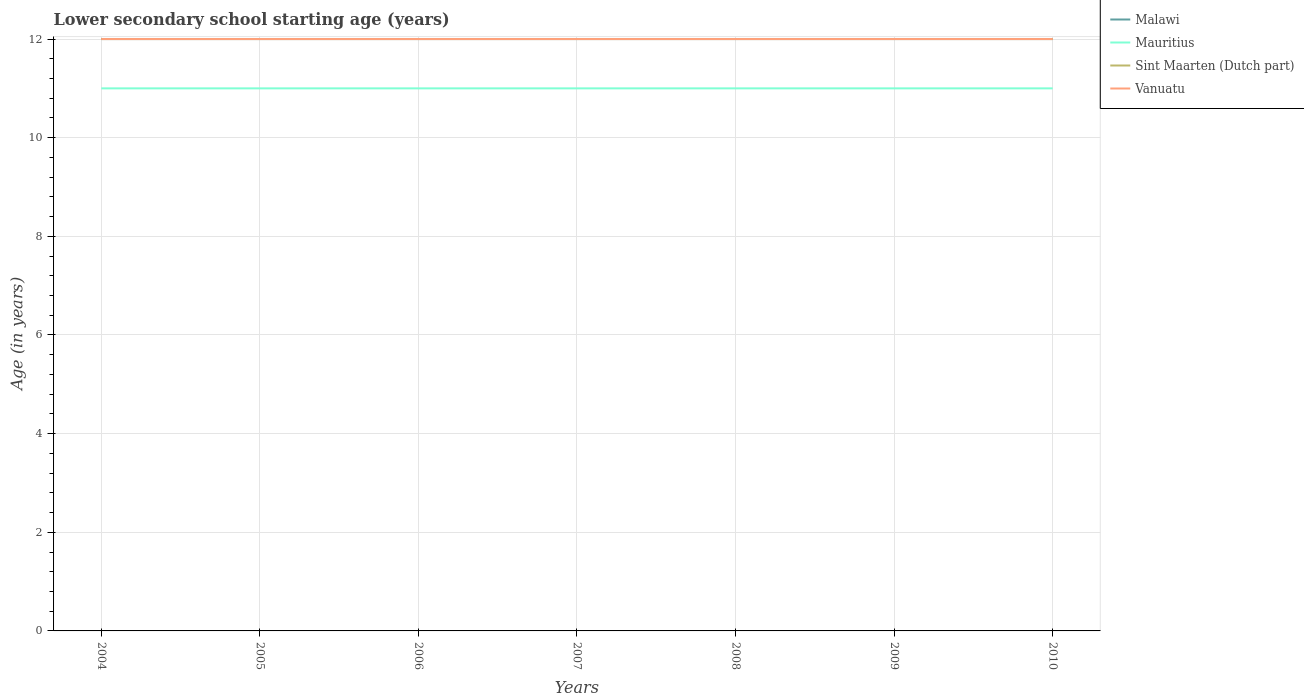Does the line corresponding to Vanuatu intersect with the line corresponding to Malawi?
Your response must be concise. Yes. Across all years, what is the maximum lower secondary school starting age of children in Sint Maarten (Dutch part)?
Your response must be concise. 12. In which year was the lower secondary school starting age of children in Malawi maximum?
Ensure brevity in your answer.  2004. What is the difference between the highest and the second highest lower secondary school starting age of children in Malawi?
Provide a short and direct response. 0. What is the difference between the highest and the lowest lower secondary school starting age of children in Mauritius?
Give a very brief answer. 0. How many lines are there?
Your answer should be very brief. 4. What is the difference between two consecutive major ticks on the Y-axis?
Your answer should be compact. 2. Are the values on the major ticks of Y-axis written in scientific E-notation?
Provide a succinct answer. No. Does the graph contain any zero values?
Provide a short and direct response. No. Does the graph contain grids?
Your response must be concise. Yes. Where does the legend appear in the graph?
Make the answer very short. Top right. How many legend labels are there?
Make the answer very short. 4. How are the legend labels stacked?
Give a very brief answer. Vertical. What is the title of the graph?
Give a very brief answer. Lower secondary school starting age (years). Does "Estonia" appear as one of the legend labels in the graph?
Make the answer very short. No. What is the label or title of the Y-axis?
Give a very brief answer. Age (in years). What is the Age (in years) of Malawi in 2004?
Offer a very short reply. 12. What is the Age (in years) in Mauritius in 2004?
Provide a short and direct response. 11. What is the Age (in years) in Sint Maarten (Dutch part) in 2004?
Your answer should be compact. 12. What is the Age (in years) of Mauritius in 2005?
Your answer should be very brief. 11. What is the Age (in years) in Sint Maarten (Dutch part) in 2005?
Keep it short and to the point. 12. What is the Age (in years) in Vanuatu in 2005?
Your answer should be very brief. 12. What is the Age (in years) in Malawi in 2007?
Provide a succinct answer. 12. What is the Age (in years) of Mauritius in 2007?
Ensure brevity in your answer.  11. What is the Age (in years) in Vanuatu in 2007?
Your response must be concise. 12. What is the Age (in years) in Mauritius in 2008?
Provide a short and direct response. 11. What is the Age (in years) of Sint Maarten (Dutch part) in 2008?
Your answer should be compact. 12. What is the Age (in years) in Malawi in 2009?
Offer a terse response. 12. What is the Age (in years) in Mauritius in 2009?
Provide a short and direct response. 11. What is the Age (in years) in Sint Maarten (Dutch part) in 2009?
Give a very brief answer. 12. What is the Age (in years) of Vanuatu in 2009?
Keep it short and to the point. 12. What is the Age (in years) in Mauritius in 2010?
Your answer should be very brief. 11. What is the Age (in years) of Sint Maarten (Dutch part) in 2010?
Ensure brevity in your answer.  12. What is the Age (in years) in Vanuatu in 2010?
Keep it short and to the point. 12. Across all years, what is the maximum Age (in years) of Malawi?
Your answer should be very brief. 12. Across all years, what is the maximum Age (in years) of Mauritius?
Provide a short and direct response. 11. Across all years, what is the maximum Age (in years) in Vanuatu?
Give a very brief answer. 12. Across all years, what is the minimum Age (in years) in Sint Maarten (Dutch part)?
Give a very brief answer. 12. What is the total Age (in years) of Mauritius in the graph?
Keep it short and to the point. 77. What is the difference between the Age (in years) of Mauritius in 2004 and that in 2005?
Make the answer very short. 0. What is the difference between the Age (in years) of Vanuatu in 2004 and that in 2005?
Provide a succinct answer. 0. What is the difference between the Age (in years) in Mauritius in 2004 and that in 2006?
Keep it short and to the point. 0. What is the difference between the Age (in years) of Sint Maarten (Dutch part) in 2004 and that in 2006?
Your answer should be very brief. 0. What is the difference between the Age (in years) in Vanuatu in 2004 and that in 2006?
Your answer should be compact. 0. What is the difference between the Age (in years) of Malawi in 2004 and that in 2007?
Give a very brief answer. 0. What is the difference between the Age (in years) in Mauritius in 2004 and that in 2007?
Your answer should be compact. 0. What is the difference between the Age (in years) in Sint Maarten (Dutch part) in 2004 and that in 2007?
Provide a succinct answer. 0. What is the difference between the Age (in years) of Vanuatu in 2004 and that in 2007?
Give a very brief answer. 0. What is the difference between the Age (in years) in Mauritius in 2004 and that in 2008?
Offer a very short reply. 0. What is the difference between the Age (in years) of Sint Maarten (Dutch part) in 2004 and that in 2008?
Offer a very short reply. 0. What is the difference between the Age (in years) in Vanuatu in 2004 and that in 2008?
Provide a succinct answer. 0. What is the difference between the Age (in years) in Sint Maarten (Dutch part) in 2004 and that in 2009?
Give a very brief answer. 0. What is the difference between the Age (in years) of Vanuatu in 2004 and that in 2009?
Make the answer very short. 0. What is the difference between the Age (in years) in Malawi in 2004 and that in 2010?
Your answer should be very brief. 0. What is the difference between the Age (in years) in Malawi in 2005 and that in 2006?
Your response must be concise. 0. What is the difference between the Age (in years) in Mauritius in 2005 and that in 2006?
Offer a very short reply. 0. What is the difference between the Age (in years) of Sint Maarten (Dutch part) in 2005 and that in 2007?
Make the answer very short. 0. What is the difference between the Age (in years) of Vanuatu in 2005 and that in 2007?
Keep it short and to the point. 0. What is the difference between the Age (in years) of Vanuatu in 2005 and that in 2008?
Offer a terse response. 0. What is the difference between the Age (in years) of Malawi in 2005 and that in 2009?
Make the answer very short. 0. What is the difference between the Age (in years) of Sint Maarten (Dutch part) in 2005 and that in 2009?
Provide a short and direct response. 0. What is the difference between the Age (in years) of Vanuatu in 2005 and that in 2009?
Offer a terse response. 0. What is the difference between the Age (in years) of Vanuatu in 2005 and that in 2010?
Give a very brief answer. 0. What is the difference between the Age (in years) of Sint Maarten (Dutch part) in 2006 and that in 2007?
Keep it short and to the point. 0. What is the difference between the Age (in years) of Malawi in 2006 and that in 2008?
Your answer should be compact. 0. What is the difference between the Age (in years) of Vanuatu in 2006 and that in 2008?
Make the answer very short. 0. What is the difference between the Age (in years) of Sint Maarten (Dutch part) in 2006 and that in 2009?
Offer a very short reply. 0. What is the difference between the Age (in years) of Sint Maarten (Dutch part) in 2006 and that in 2010?
Make the answer very short. 0. What is the difference between the Age (in years) in Malawi in 2007 and that in 2008?
Your response must be concise. 0. What is the difference between the Age (in years) in Mauritius in 2007 and that in 2008?
Ensure brevity in your answer.  0. What is the difference between the Age (in years) in Sint Maarten (Dutch part) in 2007 and that in 2008?
Your response must be concise. 0. What is the difference between the Age (in years) of Malawi in 2007 and that in 2009?
Keep it short and to the point. 0. What is the difference between the Age (in years) of Mauritius in 2007 and that in 2009?
Provide a short and direct response. 0. What is the difference between the Age (in years) in Vanuatu in 2007 and that in 2009?
Provide a short and direct response. 0. What is the difference between the Age (in years) in Malawi in 2007 and that in 2010?
Your answer should be very brief. 0. What is the difference between the Age (in years) in Malawi in 2008 and that in 2009?
Ensure brevity in your answer.  0. What is the difference between the Age (in years) of Sint Maarten (Dutch part) in 2008 and that in 2009?
Your answer should be compact. 0. What is the difference between the Age (in years) in Vanuatu in 2008 and that in 2009?
Your response must be concise. 0. What is the difference between the Age (in years) in Mauritius in 2008 and that in 2010?
Keep it short and to the point. 0. What is the difference between the Age (in years) in Sint Maarten (Dutch part) in 2008 and that in 2010?
Your answer should be compact. 0. What is the difference between the Age (in years) in Vanuatu in 2008 and that in 2010?
Your answer should be very brief. 0. What is the difference between the Age (in years) in Malawi in 2009 and that in 2010?
Give a very brief answer. 0. What is the difference between the Age (in years) of Mauritius in 2009 and that in 2010?
Your response must be concise. 0. What is the difference between the Age (in years) in Malawi in 2004 and the Age (in years) in Mauritius in 2005?
Your answer should be very brief. 1. What is the difference between the Age (in years) of Malawi in 2004 and the Age (in years) of Sint Maarten (Dutch part) in 2005?
Ensure brevity in your answer.  0. What is the difference between the Age (in years) in Malawi in 2004 and the Age (in years) in Vanuatu in 2005?
Your answer should be very brief. 0. What is the difference between the Age (in years) of Sint Maarten (Dutch part) in 2004 and the Age (in years) of Vanuatu in 2005?
Ensure brevity in your answer.  0. What is the difference between the Age (in years) in Malawi in 2004 and the Age (in years) in Mauritius in 2006?
Give a very brief answer. 1. What is the difference between the Age (in years) in Malawi in 2004 and the Age (in years) in Vanuatu in 2006?
Your answer should be compact. 0. What is the difference between the Age (in years) of Mauritius in 2004 and the Age (in years) of Sint Maarten (Dutch part) in 2006?
Ensure brevity in your answer.  -1. What is the difference between the Age (in years) in Sint Maarten (Dutch part) in 2004 and the Age (in years) in Vanuatu in 2006?
Keep it short and to the point. 0. What is the difference between the Age (in years) of Malawi in 2004 and the Age (in years) of Mauritius in 2007?
Offer a terse response. 1. What is the difference between the Age (in years) of Malawi in 2004 and the Age (in years) of Sint Maarten (Dutch part) in 2007?
Provide a short and direct response. 0. What is the difference between the Age (in years) of Mauritius in 2004 and the Age (in years) of Sint Maarten (Dutch part) in 2007?
Provide a succinct answer. -1. What is the difference between the Age (in years) of Mauritius in 2004 and the Age (in years) of Vanuatu in 2007?
Provide a short and direct response. -1. What is the difference between the Age (in years) in Malawi in 2004 and the Age (in years) in Sint Maarten (Dutch part) in 2008?
Your answer should be compact. 0. What is the difference between the Age (in years) of Malawi in 2004 and the Age (in years) of Vanuatu in 2008?
Give a very brief answer. 0. What is the difference between the Age (in years) of Mauritius in 2004 and the Age (in years) of Vanuatu in 2008?
Ensure brevity in your answer.  -1. What is the difference between the Age (in years) in Sint Maarten (Dutch part) in 2004 and the Age (in years) in Vanuatu in 2008?
Make the answer very short. 0. What is the difference between the Age (in years) in Mauritius in 2004 and the Age (in years) in Vanuatu in 2009?
Keep it short and to the point. -1. What is the difference between the Age (in years) of Malawi in 2004 and the Age (in years) of Sint Maarten (Dutch part) in 2010?
Ensure brevity in your answer.  0. What is the difference between the Age (in years) of Sint Maarten (Dutch part) in 2004 and the Age (in years) of Vanuatu in 2010?
Make the answer very short. 0. What is the difference between the Age (in years) of Malawi in 2005 and the Age (in years) of Mauritius in 2006?
Keep it short and to the point. 1. What is the difference between the Age (in years) of Malawi in 2005 and the Age (in years) of Sint Maarten (Dutch part) in 2006?
Offer a very short reply. 0. What is the difference between the Age (in years) in Malawi in 2005 and the Age (in years) in Vanuatu in 2006?
Keep it short and to the point. 0. What is the difference between the Age (in years) in Mauritius in 2005 and the Age (in years) in Sint Maarten (Dutch part) in 2006?
Provide a short and direct response. -1. What is the difference between the Age (in years) in Malawi in 2005 and the Age (in years) in Mauritius in 2007?
Ensure brevity in your answer.  1. What is the difference between the Age (in years) of Mauritius in 2005 and the Age (in years) of Sint Maarten (Dutch part) in 2007?
Your answer should be compact. -1. What is the difference between the Age (in years) of Mauritius in 2005 and the Age (in years) of Vanuatu in 2007?
Ensure brevity in your answer.  -1. What is the difference between the Age (in years) in Sint Maarten (Dutch part) in 2005 and the Age (in years) in Vanuatu in 2007?
Provide a succinct answer. 0. What is the difference between the Age (in years) in Malawi in 2005 and the Age (in years) in Sint Maarten (Dutch part) in 2008?
Your answer should be compact. 0. What is the difference between the Age (in years) of Malawi in 2005 and the Age (in years) of Vanuatu in 2008?
Your response must be concise. 0. What is the difference between the Age (in years) in Malawi in 2005 and the Age (in years) in Sint Maarten (Dutch part) in 2009?
Provide a succinct answer. 0. What is the difference between the Age (in years) in Malawi in 2005 and the Age (in years) in Vanuatu in 2009?
Ensure brevity in your answer.  0. What is the difference between the Age (in years) in Mauritius in 2005 and the Age (in years) in Sint Maarten (Dutch part) in 2009?
Provide a short and direct response. -1. What is the difference between the Age (in years) in Malawi in 2005 and the Age (in years) in Mauritius in 2010?
Offer a very short reply. 1. What is the difference between the Age (in years) of Malawi in 2005 and the Age (in years) of Sint Maarten (Dutch part) in 2010?
Give a very brief answer. 0. What is the difference between the Age (in years) of Malawi in 2005 and the Age (in years) of Vanuatu in 2010?
Provide a short and direct response. 0. What is the difference between the Age (in years) in Mauritius in 2005 and the Age (in years) in Vanuatu in 2010?
Your response must be concise. -1. What is the difference between the Age (in years) in Sint Maarten (Dutch part) in 2005 and the Age (in years) in Vanuatu in 2010?
Keep it short and to the point. 0. What is the difference between the Age (in years) of Malawi in 2006 and the Age (in years) of Mauritius in 2007?
Your answer should be very brief. 1. What is the difference between the Age (in years) of Mauritius in 2006 and the Age (in years) of Vanuatu in 2007?
Provide a short and direct response. -1. What is the difference between the Age (in years) in Malawi in 2006 and the Age (in years) in Mauritius in 2008?
Provide a short and direct response. 1. What is the difference between the Age (in years) of Malawi in 2006 and the Age (in years) of Vanuatu in 2008?
Your answer should be compact. 0. What is the difference between the Age (in years) in Mauritius in 2006 and the Age (in years) in Sint Maarten (Dutch part) in 2008?
Provide a succinct answer. -1. What is the difference between the Age (in years) in Sint Maarten (Dutch part) in 2006 and the Age (in years) in Vanuatu in 2008?
Keep it short and to the point. 0. What is the difference between the Age (in years) of Malawi in 2006 and the Age (in years) of Mauritius in 2009?
Make the answer very short. 1. What is the difference between the Age (in years) in Malawi in 2006 and the Age (in years) in Sint Maarten (Dutch part) in 2009?
Your answer should be very brief. 0. What is the difference between the Age (in years) in Malawi in 2006 and the Age (in years) in Vanuatu in 2009?
Keep it short and to the point. 0. What is the difference between the Age (in years) in Mauritius in 2006 and the Age (in years) in Sint Maarten (Dutch part) in 2009?
Keep it short and to the point. -1. What is the difference between the Age (in years) of Mauritius in 2006 and the Age (in years) of Vanuatu in 2009?
Provide a succinct answer. -1. What is the difference between the Age (in years) of Malawi in 2006 and the Age (in years) of Mauritius in 2010?
Offer a very short reply. 1. What is the difference between the Age (in years) in Malawi in 2006 and the Age (in years) in Vanuatu in 2010?
Your answer should be very brief. 0. What is the difference between the Age (in years) of Mauritius in 2006 and the Age (in years) of Vanuatu in 2010?
Make the answer very short. -1. What is the difference between the Age (in years) in Malawi in 2007 and the Age (in years) in Mauritius in 2008?
Your answer should be very brief. 1. What is the difference between the Age (in years) in Malawi in 2007 and the Age (in years) in Sint Maarten (Dutch part) in 2008?
Your answer should be compact. 0. What is the difference between the Age (in years) of Mauritius in 2007 and the Age (in years) of Sint Maarten (Dutch part) in 2008?
Your response must be concise. -1. What is the difference between the Age (in years) in Mauritius in 2007 and the Age (in years) in Vanuatu in 2008?
Ensure brevity in your answer.  -1. What is the difference between the Age (in years) of Sint Maarten (Dutch part) in 2007 and the Age (in years) of Vanuatu in 2008?
Keep it short and to the point. 0. What is the difference between the Age (in years) of Mauritius in 2007 and the Age (in years) of Sint Maarten (Dutch part) in 2009?
Provide a succinct answer. -1. What is the difference between the Age (in years) of Mauritius in 2007 and the Age (in years) of Vanuatu in 2009?
Offer a very short reply. -1. What is the difference between the Age (in years) in Malawi in 2007 and the Age (in years) in Mauritius in 2010?
Your response must be concise. 1. What is the difference between the Age (in years) in Malawi in 2007 and the Age (in years) in Vanuatu in 2010?
Your answer should be compact. 0. What is the difference between the Age (in years) in Mauritius in 2007 and the Age (in years) in Sint Maarten (Dutch part) in 2010?
Provide a succinct answer. -1. What is the difference between the Age (in years) of Mauritius in 2007 and the Age (in years) of Vanuatu in 2010?
Give a very brief answer. -1. What is the difference between the Age (in years) of Sint Maarten (Dutch part) in 2007 and the Age (in years) of Vanuatu in 2010?
Offer a very short reply. 0. What is the difference between the Age (in years) of Malawi in 2008 and the Age (in years) of Mauritius in 2009?
Your answer should be very brief. 1. What is the difference between the Age (in years) of Malawi in 2008 and the Age (in years) of Sint Maarten (Dutch part) in 2009?
Provide a short and direct response. 0. What is the difference between the Age (in years) of Sint Maarten (Dutch part) in 2008 and the Age (in years) of Vanuatu in 2009?
Your answer should be compact. 0. What is the difference between the Age (in years) of Malawi in 2008 and the Age (in years) of Vanuatu in 2010?
Offer a very short reply. 0. What is the difference between the Age (in years) in Mauritius in 2008 and the Age (in years) in Sint Maarten (Dutch part) in 2010?
Give a very brief answer. -1. What is the difference between the Age (in years) in Mauritius in 2008 and the Age (in years) in Vanuatu in 2010?
Ensure brevity in your answer.  -1. What is the difference between the Age (in years) in Sint Maarten (Dutch part) in 2008 and the Age (in years) in Vanuatu in 2010?
Offer a very short reply. 0. What is the difference between the Age (in years) of Malawi in 2009 and the Age (in years) of Mauritius in 2010?
Your response must be concise. 1. What is the difference between the Age (in years) in Malawi in 2009 and the Age (in years) in Sint Maarten (Dutch part) in 2010?
Provide a succinct answer. 0. What is the difference between the Age (in years) in Malawi in 2009 and the Age (in years) in Vanuatu in 2010?
Make the answer very short. 0. What is the difference between the Age (in years) of Mauritius in 2009 and the Age (in years) of Sint Maarten (Dutch part) in 2010?
Give a very brief answer. -1. What is the difference between the Age (in years) in Mauritius in 2009 and the Age (in years) in Vanuatu in 2010?
Your response must be concise. -1. What is the difference between the Age (in years) of Sint Maarten (Dutch part) in 2009 and the Age (in years) of Vanuatu in 2010?
Your response must be concise. 0. What is the average Age (in years) of Malawi per year?
Keep it short and to the point. 12. What is the average Age (in years) of Mauritius per year?
Your response must be concise. 11. What is the average Age (in years) in Sint Maarten (Dutch part) per year?
Offer a very short reply. 12. In the year 2004, what is the difference between the Age (in years) in Malawi and Age (in years) in Vanuatu?
Keep it short and to the point. 0. In the year 2004, what is the difference between the Age (in years) of Mauritius and Age (in years) of Vanuatu?
Ensure brevity in your answer.  -1. In the year 2004, what is the difference between the Age (in years) in Sint Maarten (Dutch part) and Age (in years) in Vanuatu?
Offer a very short reply. 0. In the year 2005, what is the difference between the Age (in years) of Malawi and Age (in years) of Vanuatu?
Give a very brief answer. 0. In the year 2005, what is the difference between the Age (in years) in Mauritius and Age (in years) in Vanuatu?
Make the answer very short. -1. In the year 2006, what is the difference between the Age (in years) of Malawi and Age (in years) of Sint Maarten (Dutch part)?
Give a very brief answer. 0. In the year 2006, what is the difference between the Age (in years) of Mauritius and Age (in years) of Sint Maarten (Dutch part)?
Provide a short and direct response. -1. In the year 2006, what is the difference between the Age (in years) in Sint Maarten (Dutch part) and Age (in years) in Vanuatu?
Your answer should be very brief. 0. In the year 2007, what is the difference between the Age (in years) in Malawi and Age (in years) in Mauritius?
Offer a very short reply. 1. In the year 2007, what is the difference between the Age (in years) in Malawi and Age (in years) in Vanuatu?
Ensure brevity in your answer.  0. In the year 2007, what is the difference between the Age (in years) of Mauritius and Age (in years) of Vanuatu?
Provide a short and direct response. -1. In the year 2007, what is the difference between the Age (in years) in Sint Maarten (Dutch part) and Age (in years) in Vanuatu?
Provide a short and direct response. 0. In the year 2008, what is the difference between the Age (in years) in Malawi and Age (in years) in Sint Maarten (Dutch part)?
Provide a succinct answer. 0. In the year 2008, what is the difference between the Age (in years) of Malawi and Age (in years) of Vanuatu?
Make the answer very short. 0. In the year 2008, what is the difference between the Age (in years) in Mauritius and Age (in years) in Sint Maarten (Dutch part)?
Give a very brief answer. -1. In the year 2008, what is the difference between the Age (in years) of Mauritius and Age (in years) of Vanuatu?
Make the answer very short. -1. In the year 2009, what is the difference between the Age (in years) in Malawi and Age (in years) in Sint Maarten (Dutch part)?
Offer a terse response. 0. In the year 2009, what is the difference between the Age (in years) in Malawi and Age (in years) in Vanuatu?
Ensure brevity in your answer.  0. In the year 2010, what is the difference between the Age (in years) of Mauritius and Age (in years) of Vanuatu?
Provide a short and direct response. -1. What is the ratio of the Age (in years) in Malawi in 2004 to that in 2005?
Provide a succinct answer. 1. What is the ratio of the Age (in years) of Vanuatu in 2004 to that in 2005?
Offer a very short reply. 1. What is the ratio of the Age (in years) of Mauritius in 2004 to that in 2006?
Your response must be concise. 1. What is the ratio of the Age (in years) of Sint Maarten (Dutch part) in 2004 to that in 2006?
Give a very brief answer. 1. What is the ratio of the Age (in years) in Vanuatu in 2004 to that in 2006?
Your answer should be very brief. 1. What is the ratio of the Age (in years) of Malawi in 2004 to that in 2007?
Offer a very short reply. 1. What is the ratio of the Age (in years) in Mauritius in 2004 to that in 2007?
Your answer should be very brief. 1. What is the ratio of the Age (in years) in Sint Maarten (Dutch part) in 2004 to that in 2007?
Ensure brevity in your answer.  1. What is the ratio of the Age (in years) in Vanuatu in 2004 to that in 2007?
Offer a very short reply. 1. What is the ratio of the Age (in years) in Malawi in 2004 to that in 2008?
Keep it short and to the point. 1. What is the ratio of the Age (in years) of Mauritius in 2004 to that in 2009?
Provide a succinct answer. 1. What is the ratio of the Age (in years) of Malawi in 2004 to that in 2010?
Your answer should be very brief. 1. What is the ratio of the Age (in years) of Vanuatu in 2004 to that in 2010?
Your answer should be compact. 1. What is the ratio of the Age (in years) of Malawi in 2005 to that in 2006?
Provide a short and direct response. 1. What is the ratio of the Age (in years) in Sint Maarten (Dutch part) in 2005 to that in 2006?
Your answer should be very brief. 1. What is the ratio of the Age (in years) in Vanuatu in 2005 to that in 2006?
Give a very brief answer. 1. What is the ratio of the Age (in years) of Malawi in 2005 to that in 2008?
Your answer should be very brief. 1. What is the ratio of the Age (in years) in Mauritius in 2005 to that in 2008?
Keep it short and to the point. 1. What is the ratio of the Age (in years) in Sint Maarten (Dutch part) in 2005 to that in 2008?
Give a very brief answer. 1. What is the ratio of the Age (in years) in Vanuatu in 2005 to that in 2008?
Make the answer very short. 1. What is the ratio of the Age (in years) in Mauritius in 2005 to that in 2009?
Keep it short and to the point. 1. What is the ratio of the Age (in years) of Sint Maarten (Dutch part) in 2005 to that in 2009?
Your response must be concise. 1. What is the ratio of the Age (in years) of Vanuatu in 2005 to that in 2010?
Offer a terse response. 1. What is the ratio of the Age (in years) in Malawi in 2006 to that in 2007?
Your answer should be very brief. 1. What is the ratio of the Age (in years) in Sint Maarten (Dutch part) in 2006 to that in 2007?
Provide a succinct answer. 1. What is the ratio of the Age (in years) in Vanuatu in 2006 to that in 2007?
Your answer should be very brief. 1. What is the ratio of the Age (in years) in Malawi in 2006 to that in 2008?
Your response must be concise. 1. What is the ratio of the Age (in years) in Vanuatu in 2006 to that in 2008?
Offer a terse response. 1. What is the ratio of the Age (in years) in Vanuatu in 2006 to that in 2009?
Your answer should be compact. 1. What is the ratio of the Age (in years) of Vanuatu in 2006 to that in 2010?
Provide a short and direct response. 1. What is the ratio of the Age (in years) of Sint Maarten (Dutch part) in 2007 to that in 2008?
Your response must be concise. 1. What is the ratio of the Age (in years) in Mauritius in 2007 to that in 2009?
Provide a succinct answer. 1. What is the ratio of the Age (in years) of Sint Maarten (Dutch part) in 2007 to that in 2010?
Offer a very short reply. 1. What is the ratio of the Age (in years) of Vanuatu in 2007 to that in 2010?
Give a very brief answer. 1. What is the ratio of the Age (in years) in Vanuatu in 2008 to that in 2009?
Your answer should be very brief. 1. What is the ratio of the Age (in years) of Vanuatu in 2008 to that in 2010?
Offer a very short reply. 1. What is the ratio of the Age (in years) of Vanuatu in 2009 to that in 2010?
Provide a short and direct response. 1. What is the difference between the highest and the second highest Age (in years) in Sint Maarten (Dutch part)?
Give a very brief answer. 0. What is the difference between the highest and the second highest Age (in years) of Vanuatu?
Offer a terse response. 0. What is the difference between the highest and the lowest Age (in years) in Mauritius?
Give a very brief answer. 0. What is the difference between the highest and the lowest Age (in years) in Sint Maarten (Dutch part)?
Give a very brief answer. 0. What is the difference between the highest and the lowest Age (in years) of Vanuatu?
Offer a terse response. 0. 